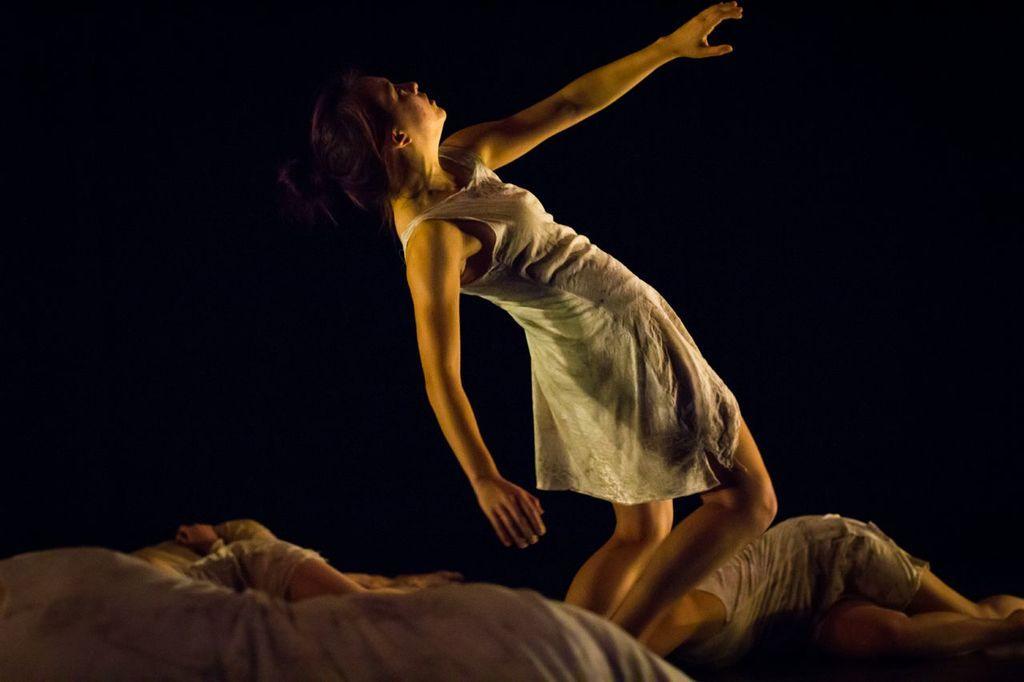Could you give a brief overview of what you see in this image? In the picture we can see a woman standing and bending backwards and she is with white top and raising her hand and in front of her we can see one person lying on the floor and back side of her also we can see some people are lying on the floor. 